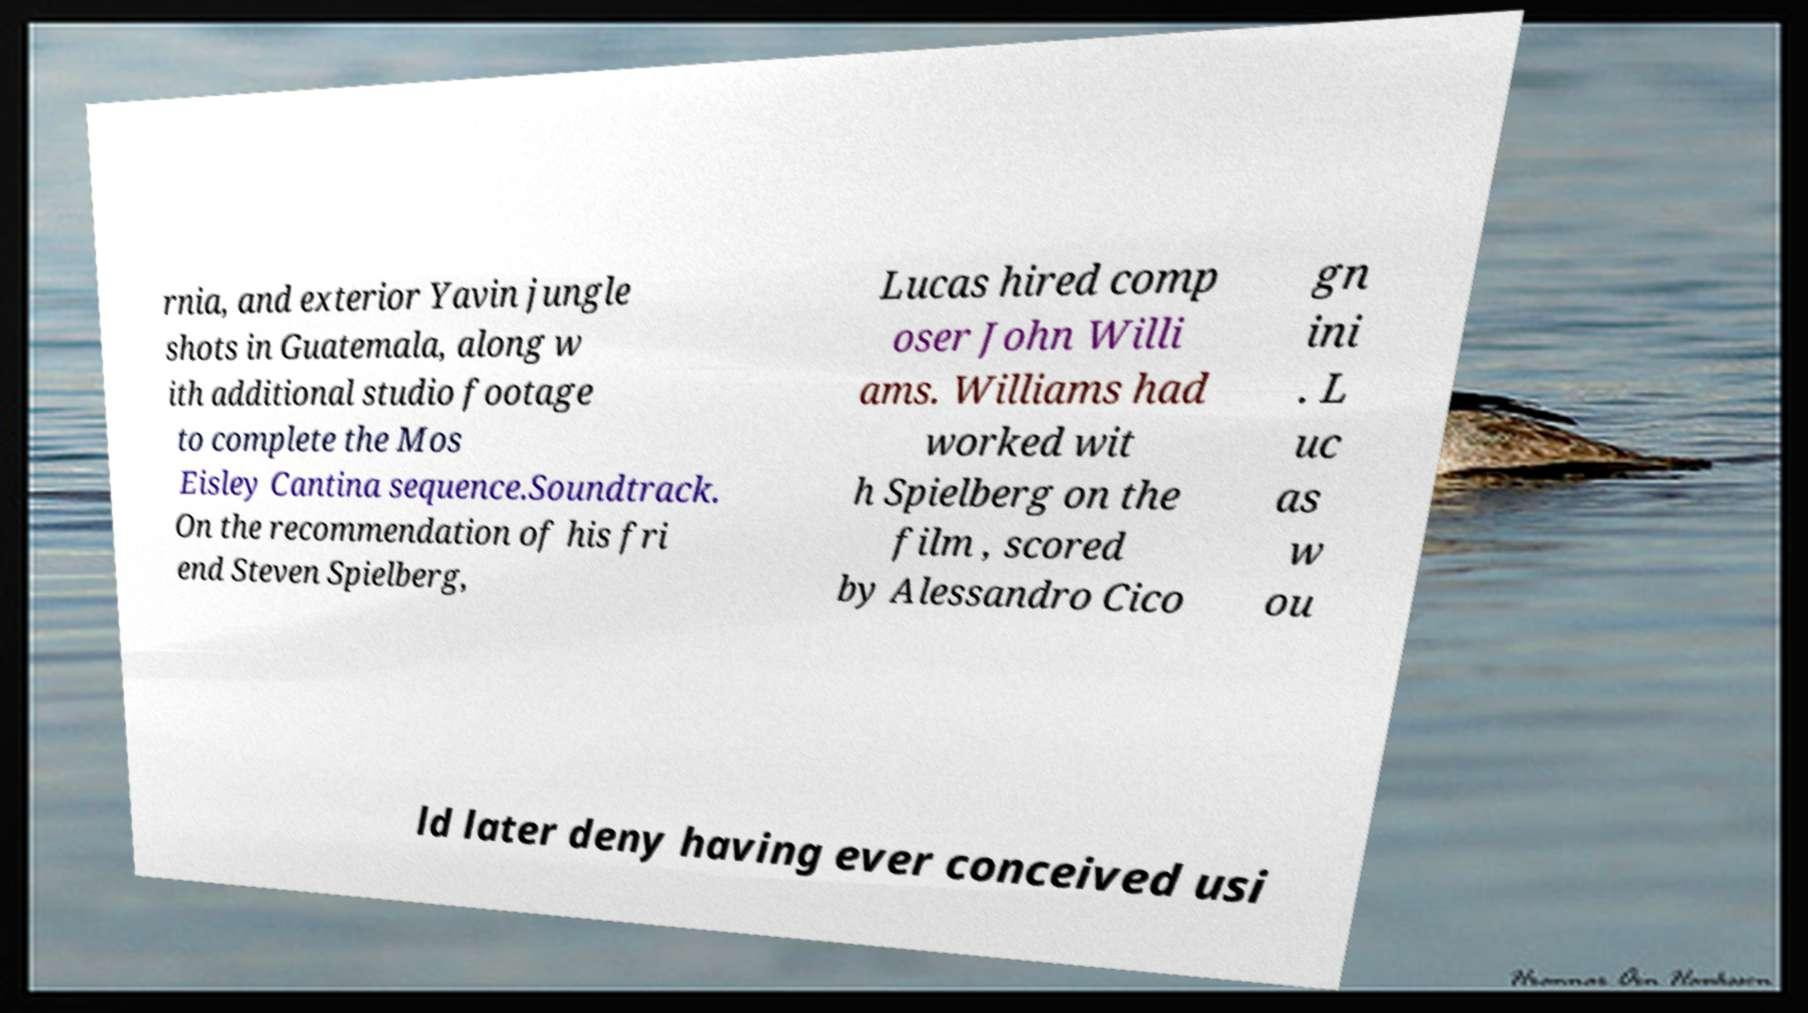What messages or text are displayed in this image? I need them in a readable, typed format. rnia, and exterior Yavin jungle shots in Guatemala, along w ith additional studio footage to complete the Mos Eisley Cantina sequence.Soundtrack. On the recommendation of his fri end Steven Spielberg, Lucas hired comp oser John Willi ams. Williams had worked wit h Spielberg on the film , scored by Alessandro Cico gn ini . L uc as w ou ld later deny having ever conceived usi 